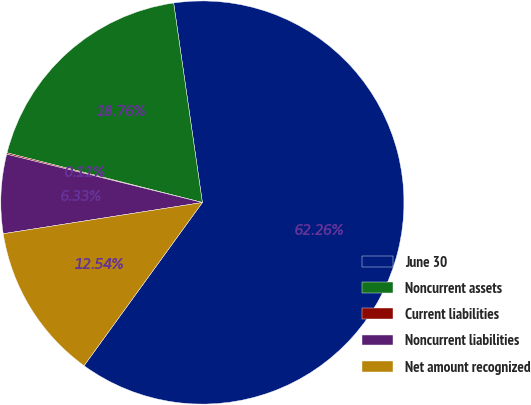Convert chart to OTSL. <chart><loc_0><loc_0><loc_500><loc_500><pie_chart><fcel>June 30<fcel>Noncurrent assets<fcel>Current liabilities<fcel>Noncurrent liabilities<fcel>Net amount recognized<nl><fcel>62.26%<fcel>18.76%<fcel>0.11%<fcel>6.33%<fcel>12.54%<nl></chart> 